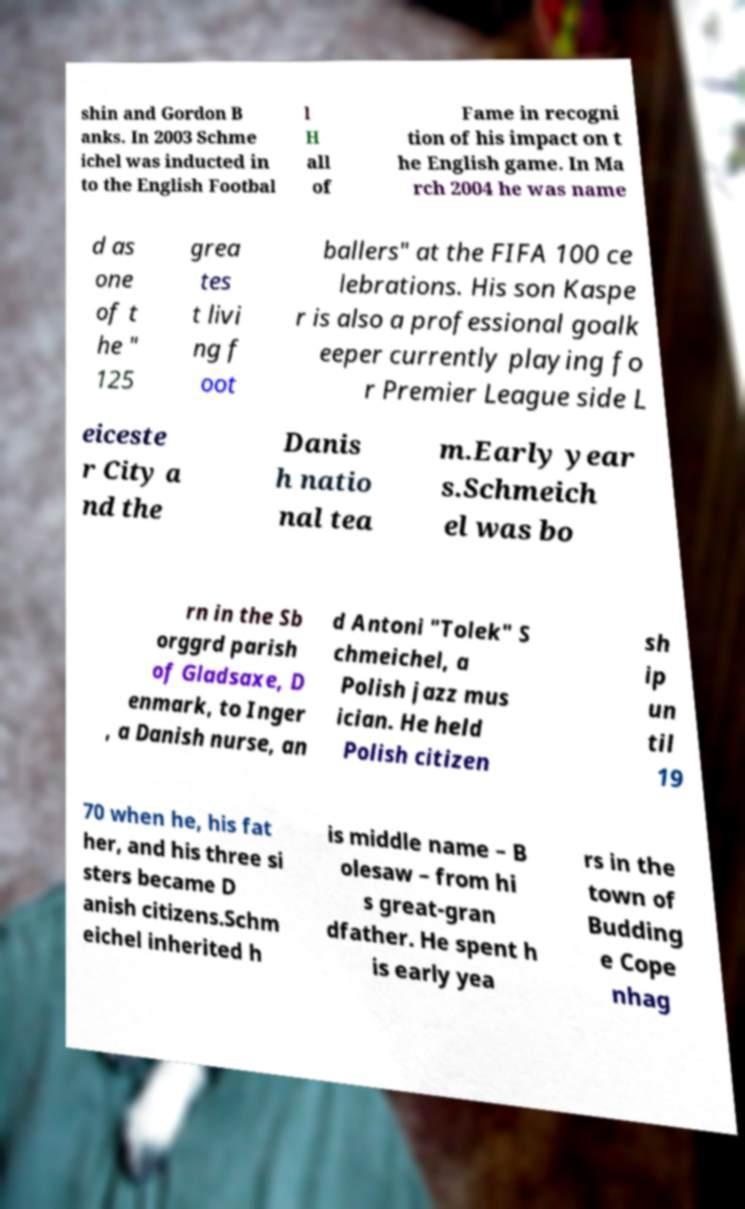Can you read and provide the text displayed in the image?This photo seems to have some interesting text. Can you extract and type it out for me? shin and Gordon B anks. In 2003 Schme ichel was inducted in to the English Footbal l H all of Fame in recogni tion of his impact on t he English game. In Ma rch 2004 he was name d as one of t he " 125 grea tes t livi ng f oot ballers" at the FIFA 100 ce lebrations. His son Kaspe r is also a professional goalk eeper currently playing fo r Premier League side L eiceste r City a nd the Danis h natio nal tea m.Early year s.Schmeich el was bo rn in the Sb orggrd parish of Gladsaxe, D enmark, to Inger , a Danish nurse, an d Antoni "Tolek" S chmeichel, a Polish jazz mus ician. He held Polish citizen sh ip un til 19 70 when he, his fat her, and his three si sters became D anish citizens.Schm eichel inherited h is middle name – B olesaw – from hi s great-gran dfather. He spent h is early yea rs in the town of Budding e Cope nhag 